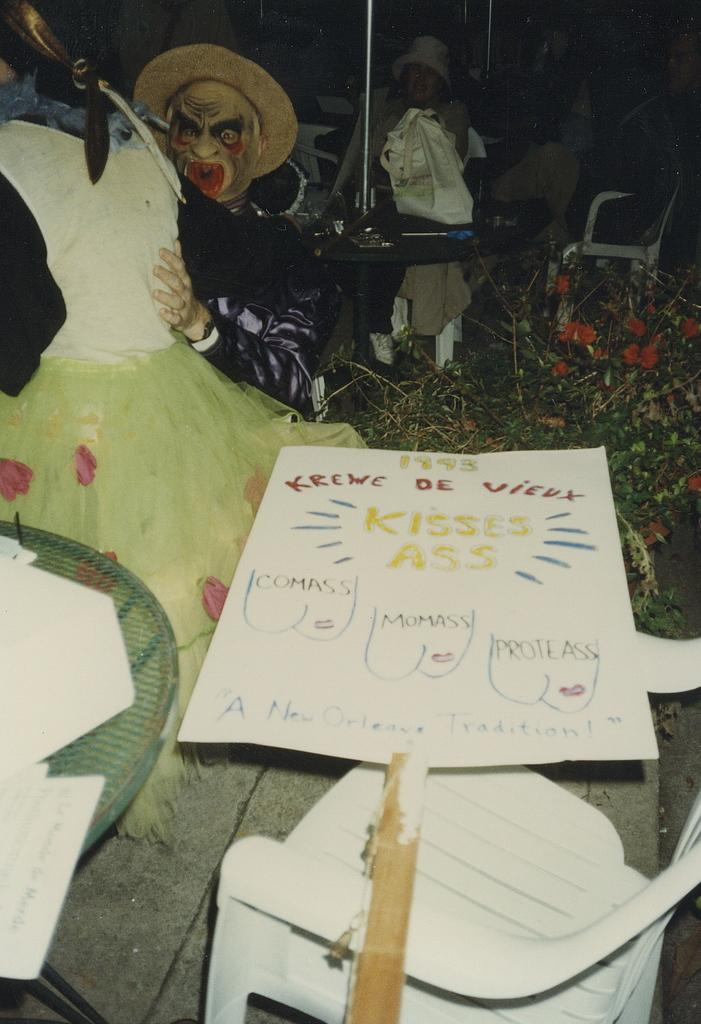What are the people in the image wearing? The people in the image are wearing costumes. What piece of furniture is at the bottom of the image? There is a chair at the bottom of the image. What object can be seen in the image that might be used for displaying information or messages? There is a board in the image. What type of living organisms can be seen in the image? Plants are visible in the image. What type of furniture is present in the image that might be used for placing objects or sitting? There are tables in the image. What items can be seen on the tables in the image? Papers are placed on the tables. What type of bird can be seen singing in the church in the image? There is no bird or church present in the image. What time of day is it in the image, based on the hour shown on a clock? There is no clock or indication of time in the image. 